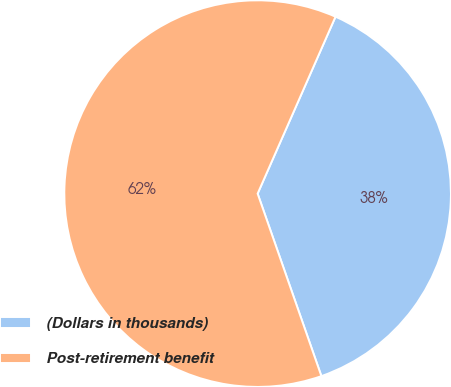Convert chart to OTSL. <chart><loc_0><loc_0><loc_500><loc_500><pie_chart><fcel>(Dollars in thousands)<fcel>Post-retirement benefit<nl><fcel>38.05%<fcel>61.95%<nl></chart> 